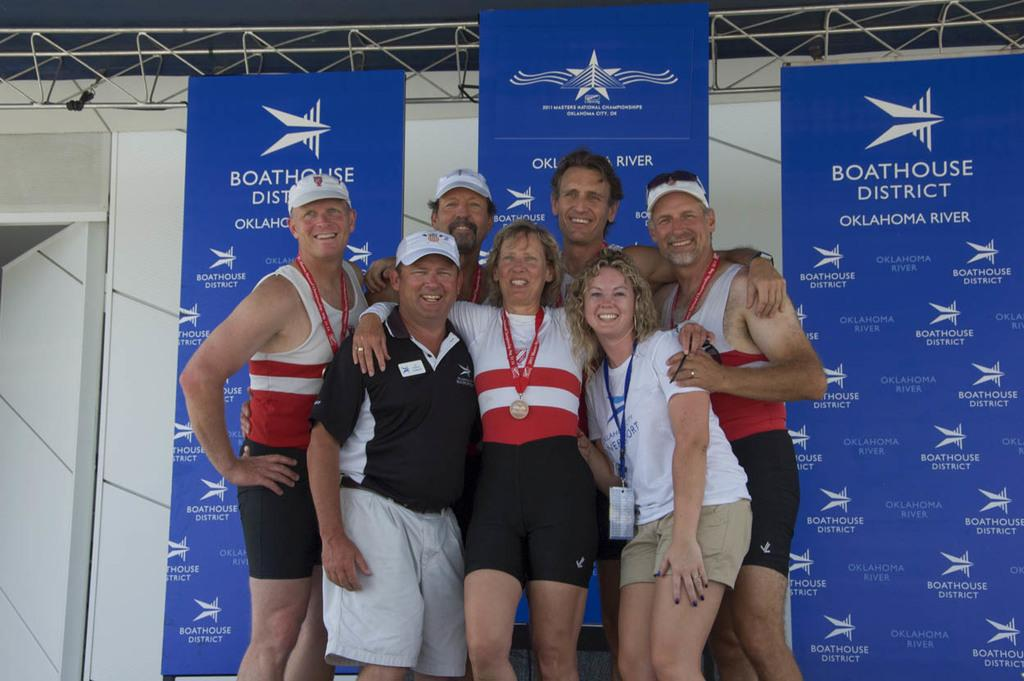<image>
Render a clear and concise summary of the photo. People posing for a photo in front of a banner that says Boathouse District. 